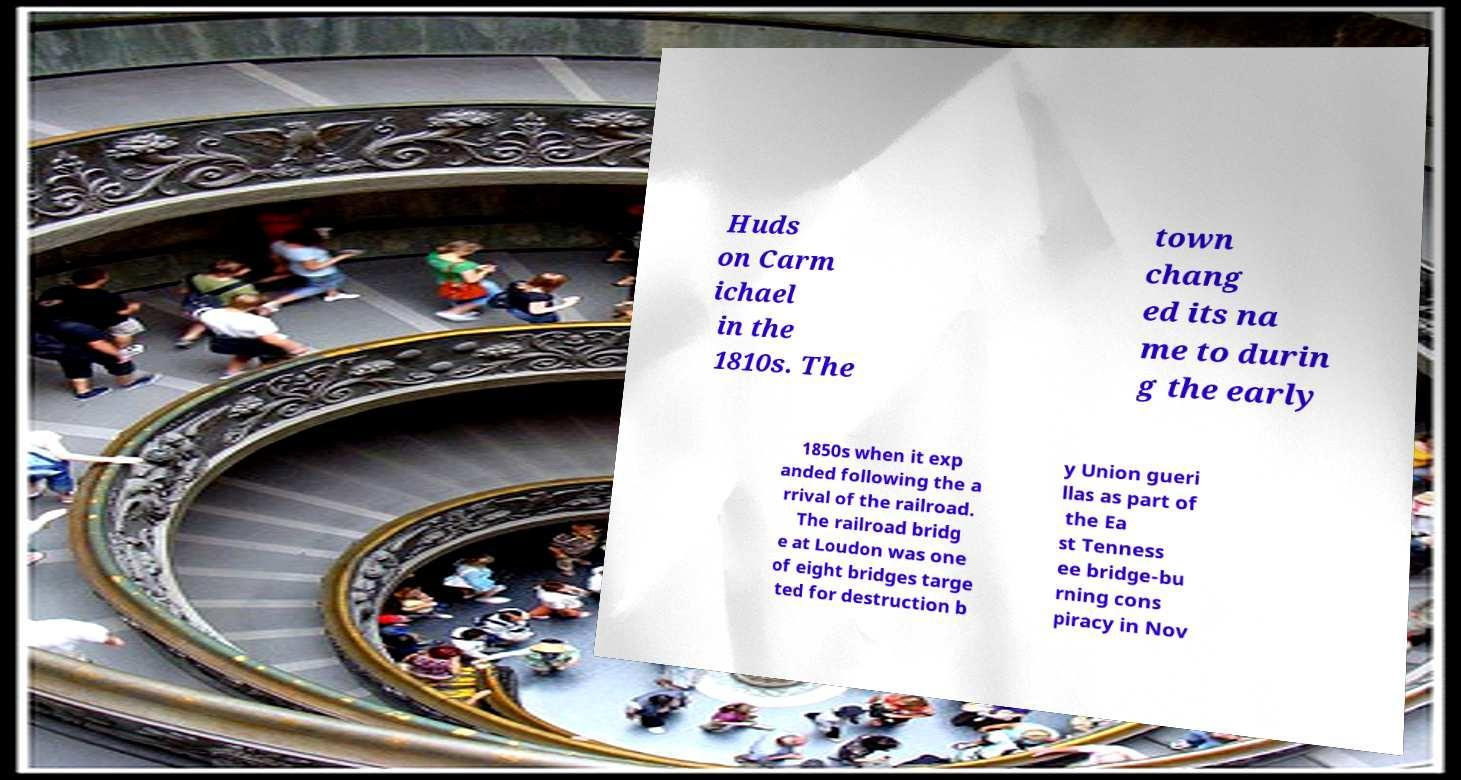For documentation purposes, I need the text within this image transcribed. Could you provide that? Huds on Carm ichael in the 1810s. The town chang ed its na me to durin g the early 1850s when it exp anded following the a rrival of the railroad. The railroad bridg e at Loudon was one of eight bridges targe ted for destruction b y Union gueri llas as part of the Ea st Tenness ee bridge-bu rning cons piracy in Nov 